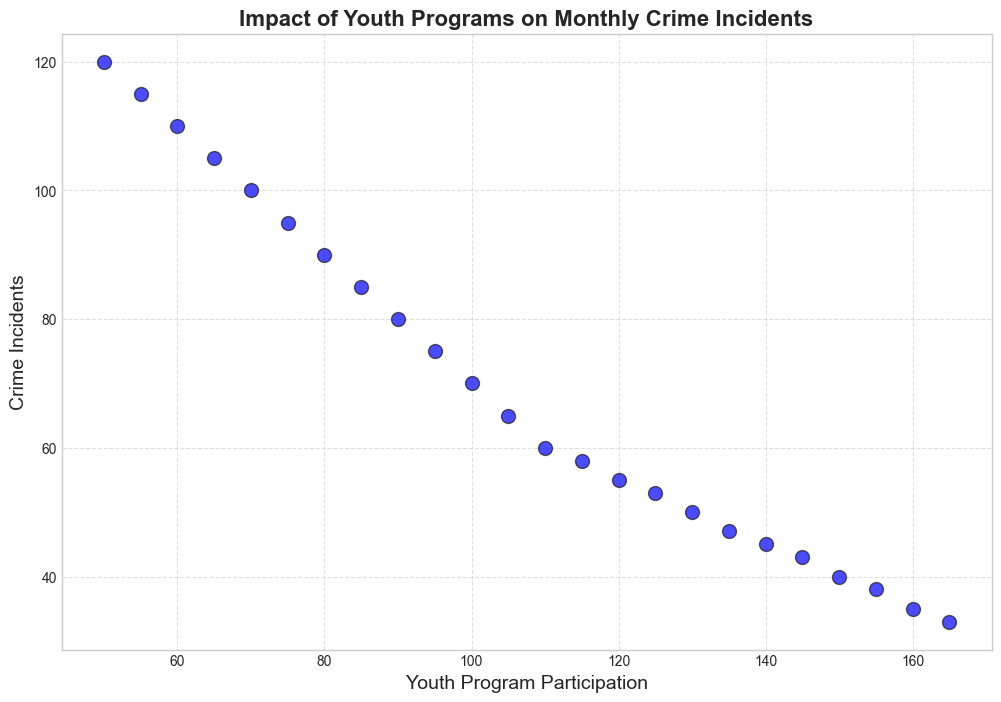what trend do you observe between Youth Program Participation and Crime Incidents from January 2022 to December 2023? The scatter plot shows that as Youth Program Participation increases, the number of Crime Incidents decreases. This suggests an inverse relationship between these two variables over the given period.
Answer: Crime Incidents decrease as Youth Program Participation increases Is there a point in time when Youth Program Participation reaches 100, and how many Crime Incidents were recorded then? The scatter plot shows that when Youth Program Participation is at 100 (November 2022), the number of Crime Incidents recorded is 70.
Answer: 70 What is the difference in Crime Incidents between the lowest and highest Youth Program Participation recorded in the plot? The lowest Youth Program Participation is 50 (January 2022) with 120 Crime Incidents, while the highest is 165 (December 2023) with 33 Crime Incidents. The difference in Crime Incidents is 120 - 33 = 87.
Answer: 87 How does the number of Crime Incidents at Youth Program Participation of 75 compare to when it is at 135? At Youth Program Participation of 75, there are 95 Crime Incidents, and at 135, there are 47 Crime Incidents. The number of Crime Incidents decreases by 95 - 47 = 48 when Youth Program Participation increases from 75 to 135.
Answer: 48 Based on the figure, at which level of Youth Program Participation does the number of Crime Incidents drop below 50? Upon examining the scatter plot, the number of Crime Incidents drops below 50 when Youth Program Participation reaches or exceeds 130 (May 2023).
Answer: 130 What is the average Crime Incidents between March 2023 and June 2023? From the scatter plot, the Crime Incidents for March 2023, April 2023, May 2023, and June 2023 are 55, 53, 50, and 47 respectively. The average is (55 + 53 + 50 + 47) / 4 = 205 / 4 = 51.25.
Answer: 51.25 Which month shows the steepest decline in Crime Incidents relative to the increase in Youth Program Participation, and what are the values? From the scatter plot, the steepest decline is observed between January 2023 and February 2023, where Youth Program Participation increases from 110 to 115, and Crime Incidents decrease from 60 to 58. The steepest decline is 60 - 58 = 2 incidents.
Answer: 2 